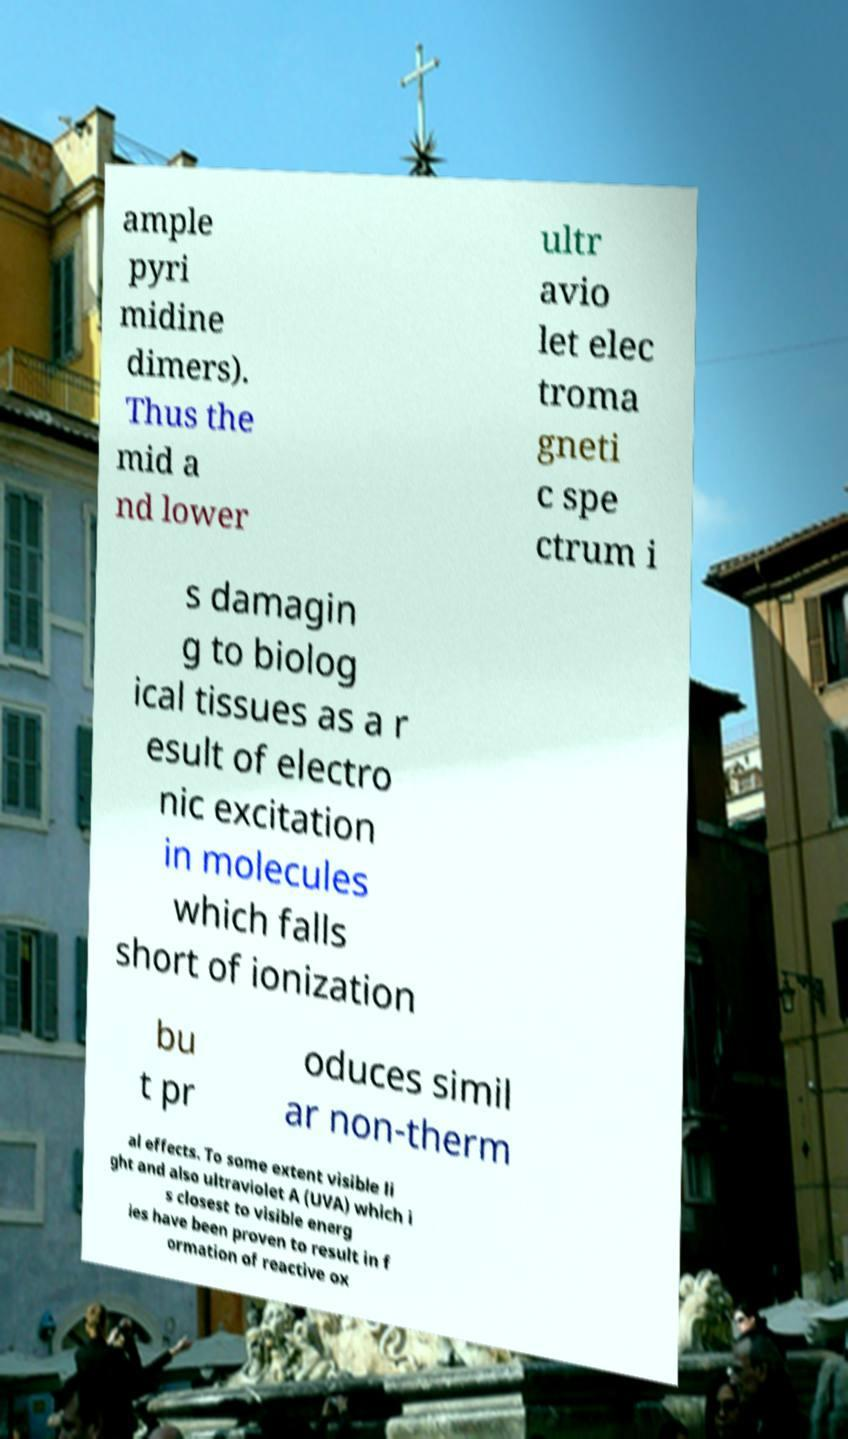I need the written content from this picture converted into text. Can you do that? ample pyri midine dimers). Thus the mid a nd lower ultr avio let elec troma gneti c spe ctrum i s damagin g to biolog ical tissues as a r esult of electro nic excitation in molecules which falls short of ionization bu t pr oduces simil ar non-therm al effects. To some extent visible li ght and also ultraviolet A (UVA) which i s closest to visible energ ies have been proven to result in f ormation of reactive ox 